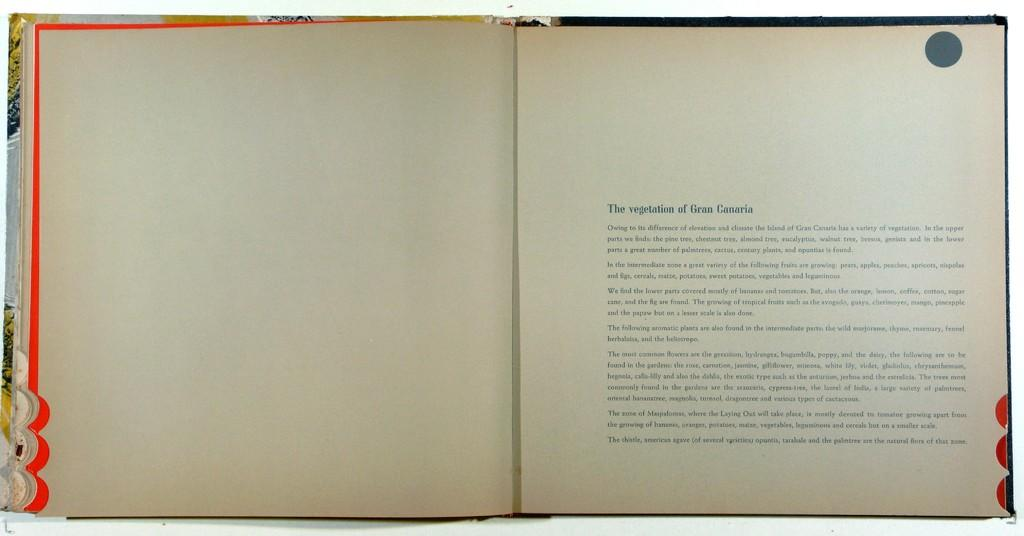Provide a one-sentence caption for the provided image. An open book with the title The vegetation of Gran Canaria and a paragraph below it. 